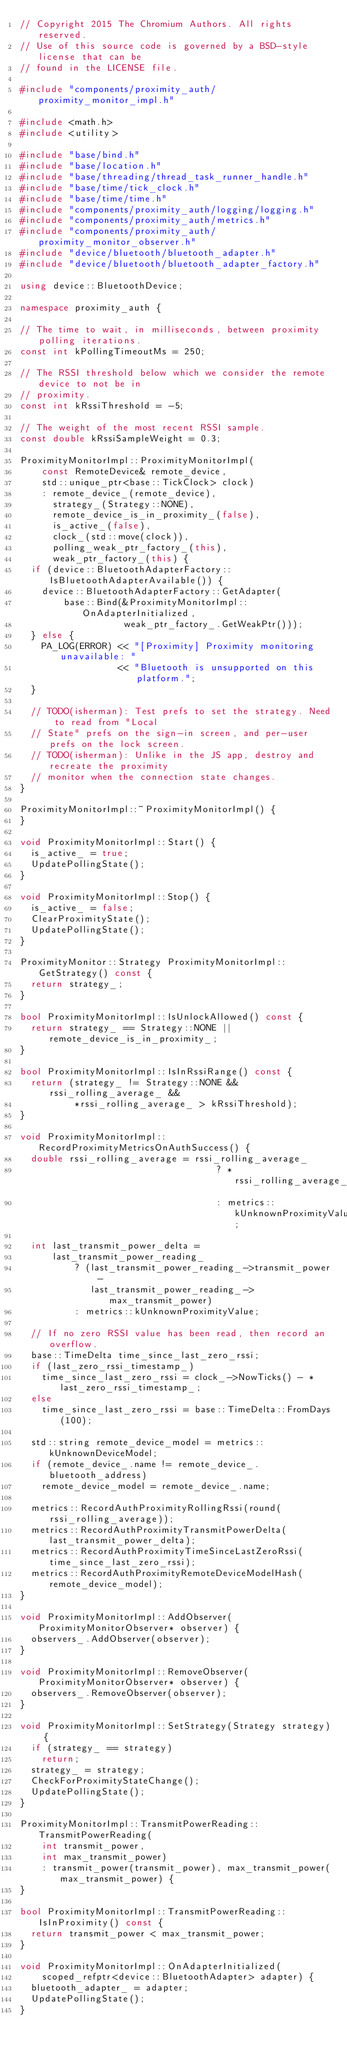Convert code to text. <code><loc_0><loc_0><loc_500><loc_500><_C++_>// Copyright 2015 The Chromium Authors. All rights reserved.
// Use of this source code is governed by a BSD-style license that can be
// found in the LICENSE file.

#include "components/proximity_auth/proximity_monitor_impl.h"

#include <math.h>
#include <utility>

#include "base/bind.h"
#include "base/location.h"
#include "base/threading/thread_task_runner_handle.h"
#include "base/time/tick_clock.h"
#include "base/time/time.h"
#include "components/proximity_auth/logging/logging.h"
#include "components/proximity_auth/metrics.h"
#include "components/proximity_auth/proximity_monitor_observer.h"
#include "device/bluetooth/bluetooth_adapter.h"
#include "device/bluetooth/bluetooth_adapter_factory.h"

using device::BluetoothDevice;

namespace proximity_auth {

// The time to wait, in milliseconds, between proximity polling iterations.
const int kPollingTimeoutMs = 250;

// The RSSI threshold below which we consider the remote device to not be in
// proximity.
const int kRssiThreshold = -5;

// The weight of the most recent RSSI sample.
const double kRssiSampleWeight = 0.3;

ProximityMonitorImpl::ProximityMonitorImpl(
    const RemoteDevice& remote_device,
    std::unique_ptr<base::TickClock> clock)
    : remote_device_(remote_device),
      strategy_(Strategy::NONE),
      remote_device_is_in_proximity_(false),
      is_active_(false),
      clock_(std::move(clock)),
      polling_weak_ptr_factory_(this),
      weak_ptr_factory_(this) {
  if (device::BluetoothAdapterFactory::IsBluetoothAdapterAvailable()) {
    device::BluetoothAdapterFactory::GetAdapter(
        base::Bind(&ProximityMonitorImpl::OnAdapterInitialized,
                   weak_ptr_factory_.GetWeakPtr()));
  } else {
    PA_LOG(ERROR) << "[Proximity] Proximity monitoring unavailable: "
                  << "Bluetooth is unsupported on this platform.";
  }

  // TODO(isherman): Test prefs to set the strategy. Need to read from "Local
  // State" prefs on the sign-in screen, and per-user prefs on the lock screen.
  // TODO(isherman): Unlike in the JS app, destroy and recreate the proximity
  // monitor when the connection state changes.
}

ProximityMonitorImpl::~ProximityMonitorImpl() {
}

void ProximityMonitorImpl::Start() {
  is_active_ = true;
  UpdatePollingState();
}

void ProximityMonitorImpl::Stop() {
  is_active_ = false;
  ClearProximityState();
  UpdatePollingState();
}

ProximityMonitor::Strategy ProximityMonitorImpl::GetStrategy() const {
  return strategy_;
}

bool ProximityMonitorImpl::IsUnlockAllowed() const {
  return strategy_ == Strategy::NONE || remote_device_is_in_proximity_;
}

bool ProximityMonitorImpl::IsInRssiRange() const {
  return (strategy_ != Strategy::NONE && rssi_rolling_average_ &&
          *rssi_rolling_average_ > kRssiThreshold);
}

void ProximityMonitorImpl::RecordProximityMetricsOnAuthSuccess() {
  double rssi_rolling_average = rssi_rolling_average_
                                    ? *rssi_rolling_average_
                                    : metrics::kUnknownProximityValue;

  int last_transmit_power_delta =
      last_transmit_power_reading_
          ? (last_transmit_power_reading_->transmit_power -
             last_transmit_power_reading_->max_transmit_power)
          : metrics::kUnknownProximityValue;

  // If no zero RSSI value has been read, then record an overflow.
  base::TimeDelta time_since_last_zero_rssi;
  if (last_zero_rssi_timestamp_)
    time_since_last_zero_rssi = clock_->NowTicks() - *last_zero_rssi_timestamp_;
  else
    time_since_last_zero_rssi = base::TimeDelta::FromDays(100);

  std::string remote_device_model = metrics::kUnknownDeviceModel;
  if (remote_device_.name != remote_device_.bluetooth_address)
    remote_device_model = remote_device_.name;

  metrics::RecordAuthProximityRollingRssi(round(rssi_rolling_average));
  metrics::RecordAuthProximityTransmitPowerDelta(last_transmit_power_delta);
  metrics::RecordAuthProximityTimeSinceLastZeroRssi(time_since_last_zero_rssi);
  metrics::RecordAuthProximityRemoteDeviceModelHash(remote_device_model);
}

void ProximityMonitorImpl::AddObserver(ProximityMonitorObserver* observer) {
  observers_.AddObserver(observer);
}

void ProximityMonitorImpl::RemoveObserver(ProximityMonitorObserver* observer) {
  observers_.RemoveObserver(observer);
}

void ProximityMonitorImpl::SetStrategy(Strategy strategy) {
  if (strategy_ == strategy)
    return;
  strategy_ = strategy;
  CheckForProximityStateChange();
  UpdatePollingState();
}

ProximityMonitorImpl::TransmitPowerReading::TransmitPowerReading(
    int transmit_power,
    int max_transmit_power)
    : transmit_power(transmit_power), max_transmit_power(max_transmit_power) {
}

bool ProximityMonitorImpl::TransmitPowerReading::IsInProximity() const {
  return transmit_power < max_transmit_power;
}

void ProximityMonitorImpl::OnAdapterInitialized(
    scoped_refptr<device::BluetoothAdapter> adapter) {
  bluetooth_adapter_ = adapter;
  UpdatePollingState();
}
</code> 